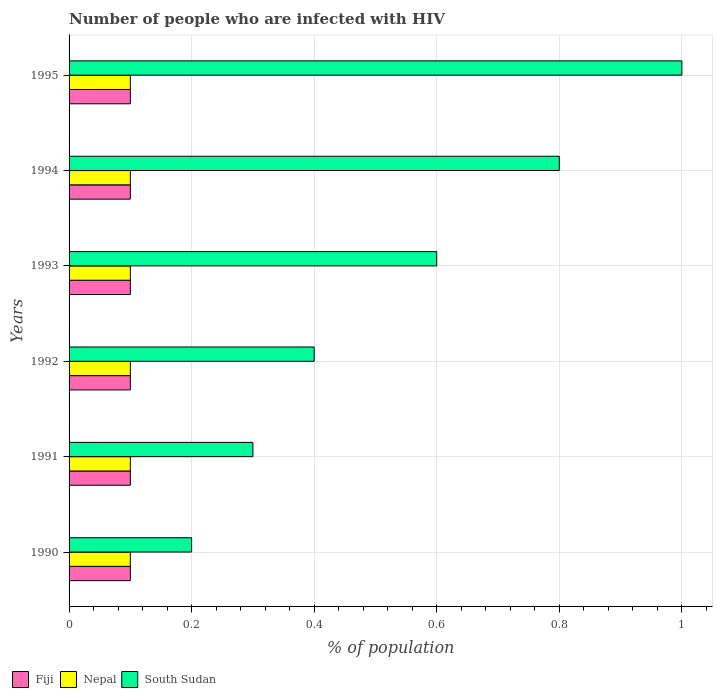How many groups of bars are there?
Offer a terse response. 6. Are the number of bars on each tick of the Y-axis equal?
Your answer should be compact. Yes. How many bars are there on the 1st tick from the bottom?
Offer a terse response. 3. What is the percentage of HIV infected population in in Fiji in 1993?
Provide a succinct answer. 0.1. Across all years, what is the maximum percentage of HIV infected population in in South Sudan?
Provide a succinct answer. 1. In which year was the percentage of HIV infected population in in South Sudan minimum?
Your response must be concise. 1990. What is the average percentage of HIV infected population in in South Sudan per year?
Give a very brief answer. 0.55. In the year 1995, what is the difference between the percentage of HIV infected population in in Nepal and percentage of HIV infected population in in South Sudan?
Ensure brevity in your answer.  -0.9. In how many years, is the percentage of HIV infected population in in Fiji greater than 0.52 %?
Make the answer very short. 0. Is the difference between the percentage of HIV infected population in in Nepal in 1991 and 1994 greater than the difference between the percentage of HIV infected population in in South Sudan in 1991 and 1994?
Keep it short and to the point. Yes. What is the difference between the highest and the second highest percentage of HIV infected population in in Nepal?
Offer a very short reply. 0. What is the difference between the highest and the lowest percentage of HIV infected population in in Nepal?
Your response must be concise. 0. In how many years, is the percentage of HIV infected population in in Nepal greater than the average percentage of HIV infected population in in Nepal taken over all years?
Provide a succinct answer. 6. What does the 3rd bar from the top in 1995 represents?
Ensure brevity in your answer.  Fiji. What does the 1st bar from the bottom in 1992 represents?
Give a very brief answer. Fiji. Are all the bars in the graph horizontal?
Keep it short and to the point. Yes. How many years are there in the graph?
Your answer should be compact. 6. Does the graph contain any zero values?
Your response must be concise. No. Where does the legend appear in the graph?
Offer a terse response. Bottom left. How many legend labels are there?
Give a very brief answer. 3. How are the legend labels stacked?
Provide a succinct answer. Horizontal. What is the title of the graph?
Your response must be concise. Number of people who are infected with HIV. Does "Cambodia" appear as one of the legend labels in the graph?
Ensure brevity in your answer.  No. What is the label or title of the X-axis?
Provide a succinct answer. % of population. What is the label or title of the Y-axis?
Give a very brief answer. Years. What is the % of population of Fiji in 1991?
Give a very brief answer. 0.1. What is the % of population of Fiji in 1992?
Provide a succinct answer. 0.1. What is the % of population in Nepal in 1992?
Offer a very short reply. 0.1. What is the % of population of South Sudan in 1993?
Keep it short and to the point. 0.6. What is the % of population of Nepal in 1994?
Ensure brevity in your answer.  0.1. What is the % of population in Nepal in 1995?
Ensure brevity in your answer.  0.1. What is the % of population in South Sudan in 1995?
Provide a short and direct response. 1. Across all years, what is the maximum % of population of South Sudan?
Provide a short and direct response. 1. Across all years, what is the minimum % of population of Fiji?
Offer a very short reply. 0.1. Across all years, what is the minimum % of population of South Sudan?
Make the answer very short. 0.2. What is the total % of population in Nepal in the graph?
Provide a short and direct response. 0.6. What is the total % of population of South Sudan in the graph?
Ensure brevity in your answer.  3.3. What is the difference between the % of population of Nepal in 1990 and that in 1991?
Your response must be concise. 0. What is the difference between the % of population in South Sudan in 1990 and that in 1991?
Your answer should be compact. -0.1. What is the difference between the % of population in Fiji in 1990 and that in 1992?
Your response must be concise. 0. What is the difference between the % of population in Nepal in 1990 and that in 1992?
Offer a very short reply. 0. What is the difference between the % of population in South Sudan in 1990 and that in 1992?
Your answer should be compact. -0.2. What is the difference between the % of population in Fiji in 1990 and that in 1993?
Offer a terse response. 0. What is the difference between the % of population in South Sudan in 1990 and that in 1993?
Provide a succinct answer. -0.4. What is the difference between the % of population of Fiji in 1990 and that in 1994?
Provide a short and direct response. 0. What is the difference between the % of population of Nepal in 1990 and that in 1994?
Make the answer very short. 0. What is the difference between the % of population in South Sudan in 1990 and that in 1994?
Make the answer very short. -0.6. What is the difference between the % of population in Nepal in 1991 and that in 1992?
Offer a very short reply. 0. What is the difference between the % of population of South Sudan in 1991 and that in 1993?
Give a very brief answer. -0.3. What is the difference between the % of population in Fiji in 1991 and that in 1994?
Your answer should be very brief. 0. What is the difference between the % of population in Nepal in 1992 and that in 1993?
Offer a very short reply. 0. What is the difference between the % of population in South Sudan in 1992 and that in 1993?
Ensure brevity in your answer.  -0.2. What is the difference between the % of population in Fiji in 1992 and that in 1994?
Your answer should be compact. 0. What is the difference between the % of population in Nepal in 1992 and that in 1994?
Offer a very short reply. 0. What is the difference between the % of population in Nepal in 1992 and that in 1995?
Give a very brief answer. 0. What is the difference between the % of population of South Sudan in 1992 and that in 1995?
Your answer should be very brief. -0.6. What is the difference between the % of population of Fiji in 1993 and that in 1995?
Give a very brief answer. 0. What is the difference between the % of population of Nepal in 1993 and that in 1995?
Make the answer very short. 0. What is the difference between the % of population of South Sudan in 1993 and that in 1995?
Give a very brief answer. -0.4. What is the difference between the % of population of Fiji in 1994 and that in 1995?
Offer a very short reply. 0. What is the difference between the % of population of Nepal in 1994 and that in 1995?
Give a very brief answer. 0. What is the difference between the % of population of Nepal in 1990 and the % of population of South Sudan in 1991?
Provide a short and direct response. -0.2. What is the difference between the % of population of Fiji in 1990 and the % of population of South Sudan in 1992?
Offer a very short reply. -0.3. What is the difference between the % of population of Fiji in 1990 and the % of population of Nepal in 1993?
Make the answer very short. 0. What is the difference between the % of population in Nepal in 1990 and the % of population in South Sudan in 1993?
Keep it short and to the point. -0.5. What is the difference between the % of population in Fiji in 1990 and the % of population in South Sudan in 1994?
Your answer should be very brief. -0.7. What is the difference between the % of population of Nepal in 1990 and the % of population of South Sudan in 1994?
Your response must be concise. -0.7. What is the difference between the % of population in Fiji in 1990 and the % of population in South Sudan in 1995?
Offer a terse response. -0.9. What is the difference between the % of population of Nepal in 1991 and the % of population of South Sudan in 1992?
Your answer should be very brief. -0.3. What is the difference between the % of population in Fiji in 1991 and the % of population in Nepal in 1993?
Make the answer very short. 0. What is the difference between the % of population in Fiji in 1991 and the % of population in South Sudan in 1993?
Ensure brevity in your answer.  -0.5. What is the difference between the % of population in Fiji in 1991 and the % of population in Nepal in 1994?
Provide a succinct answer. 0. What is the difference between the % of population in Nepal in 1991 and the % of population in South Sudan in 1995?
Ensure brevity in your answer.  -0.9. What is the difference between the % of population of Fiji in 1992 and the % of population of South Sudan in 1994?
Keep it short and to the point. -0.7. What is the difference between the % of population of Nepal in 1992 and the % of population of South Sudan in 1995?
Offer a terse response. -0.9. What is the difference between the % of population of Fiji in 1993 and the % of population of Nepal in 1994?
Your answer should be very brief. 0. What is the difference between the % of population in Nepal in 1993 and the % of population in South Sudan in 1994?
Provide a short and direct response. -0.7. What is the difference between the % of population in Fiji in 1993 and the % of population in South Sudan in 1995?
Keep it short and to the point. -0.9. What is the difference between the % of population in Nepal in 1993 and the % of population in South Sudan in 1995?
Provide a short and direct response. -0.9. What is the average % of population in Fiji per year?
Make the answer very short. 0.1. What is the average % of population of South Sudan per year?
Provide a short and direct response. 0.55. In the year 1990, what is the difference between the % of population in Fiji and % of population in Nepal?
Provide a short and direct response. 0. In the year 1991, what is the difference between the % of population in Fiji and % of population in South Sudan?
Provide a succinct answer. -0.2. In the year 1992, what is the difference between the % of population in Nepal and % of population in South Sudan?
Your answer should be very brief. -0.3. In the year 1993, what is the difference between the % of population in Nepal and % of population in South Sudan?
Give a very brief answer. -0.5. In the year 1994, what is the difference between the % of population of Fiji and % of population of Nepal?
Keep it short and to the point. 0. In the year 1994, what is the difference between the % of population in Fiji and % of population in South Sudan?
Your response must be concise. -0.7. What is the ratio of the % of population in Fiji in 1990 to that in 1992?
Provide a short and direct response. 1. What is the ratio of the % of population of Nepal in 1990 to that in 1992?
Offer a terse response. 1. What is the ratio of the % of population of South Sudan in 1990 to that in 1992?
Offer a very short reply. 0.5. What is the ratio of the % of population in Nepal in 1990 to that in 1993?
Provide a short and direct response. 1. What is the ratio of the % of population of South Sudan in 1990 to that in 1993?
Your answer should be very brief. 0.33. What is the ratio of the % of population in Fiji in 1990 to that in 1994?
Your answer should be very brief. 1. What is the ratio of the % of population in Nepal in 1990 to that in 1994?
Keep it short and to the point. 1. What is the ratio of the % of population in South Sudan in 1990 to that in 1994?
Keep it short and to the point. 0.25. What is the ratio of the % of population of Nepal in 1990 to that in 1995?
Ensure brevity in your answer.  1. What is the ratio of the % of population of Nepal in 1991 to that in 1992?
Make the answer very short. 1. What is the ratio of the % of population in Fiji in 1991 to that in 1993?
Offer a terse response. 1. What is the ratio of the % of population in Nepal in 1991 to that in 1993?
Your answer should be compact. 1. What is the ratio of the % of population in South Sudan in 1991 to that in 1994?
Make the answer very short. 0.38. What is the ratio of the % of population in Fiji in 1991 to that in 1995?
Give a very brief answer. 1. What is the ratio of the % of population of Nepal in 1991 to that in 1995?
Keep it short and to the point. 1. What is the ratio of the % of population in Fiji in 1992 to that in 1993?
Your response must be concise. 1. What is the ratio of the % of population in Nepal in 1992 to that in 1993?
Provide a short and direct response. 1. What is the ratio of the % of population in South Sudan in 1992 to that in 1993?
Provide a short and direct response. 0.67. What is the ratio of the % of population of Fiji in 1992 to that in 1995?
Offer a very short reply. 1. What is the ratio of the % of population of South Sudan in 1992 to that in 1995?
Your response must be concise. 0.4. What is the ratio of the % of population of Fiji in 1993 to that in 1994?
Offer a very short reply. 1. What is the ratio of the % of population of Nepal in 1993 to that in 1994?
Provide a short and direct response. 1. What is the ratio of the % of population of South Sudan in 1993 to that in 1994?
Your answer should be very brief. 0.75. What is the ratio of the % of population in Nepal in 1993 to that in 1995?
Your answer should be compact. 1. What is the ratio of the % of population of Fiji in 1994 to that in 1995?
Make the answer very short. 1. What is the difference between the highest and the second highest % of population in Fiji?
Keep it short and to the point. 0. What is the difference between the highest and the second highest % of population of Nepal?
Your answer should be compact. 0. What is the difference between the highest and the lowest % of population of Fiji?
Your response must be concise. 0. What is the difference between the highest and the lowest % of population of Nepal?
Offer a very short reply. 0. 